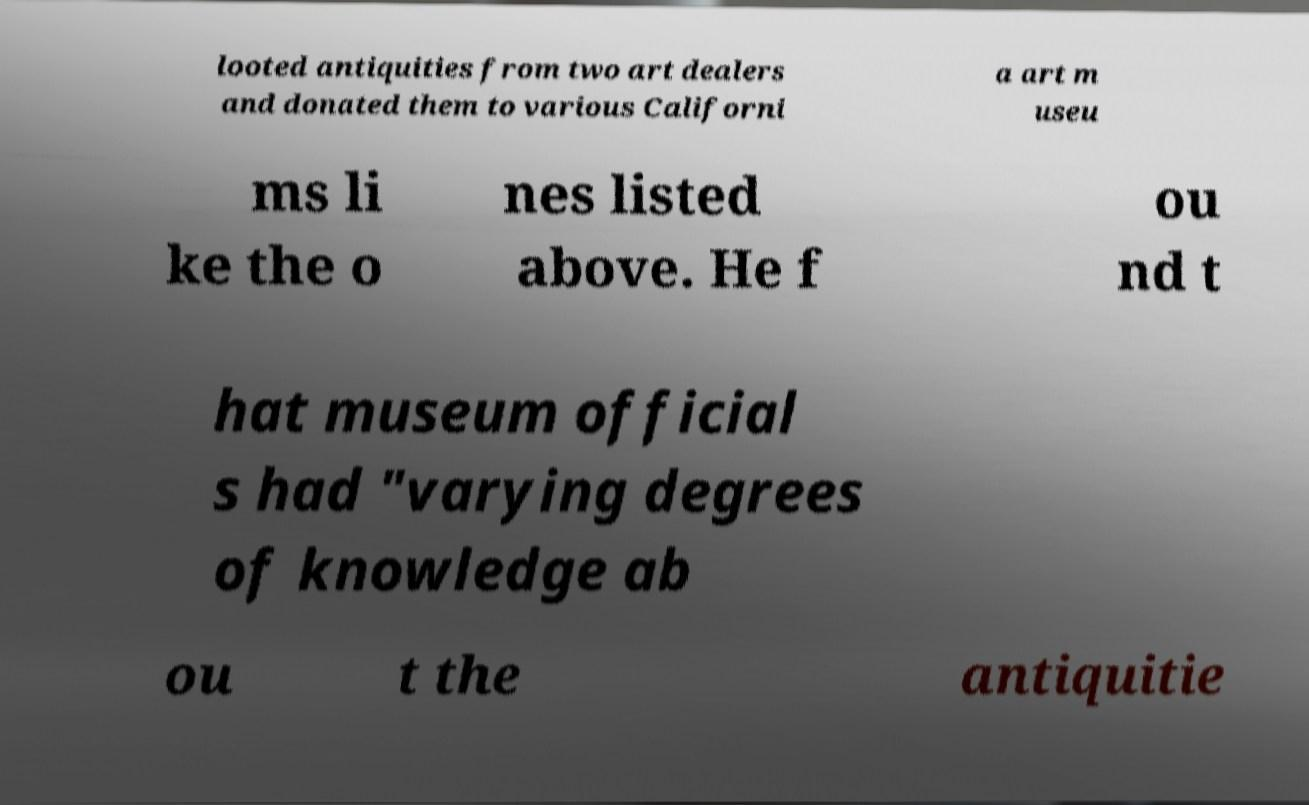Can you read and provide the text displayed in the image?This photo seems to have some interesting text. Can you extract and type it out for me? looted antiquities from two art dealers and donated them to various Californi a art m useu ms li ke the o nes listed above. He f ou nd t hat museum official s had "varying degrees of knowledge ab ou t the antiquitie 